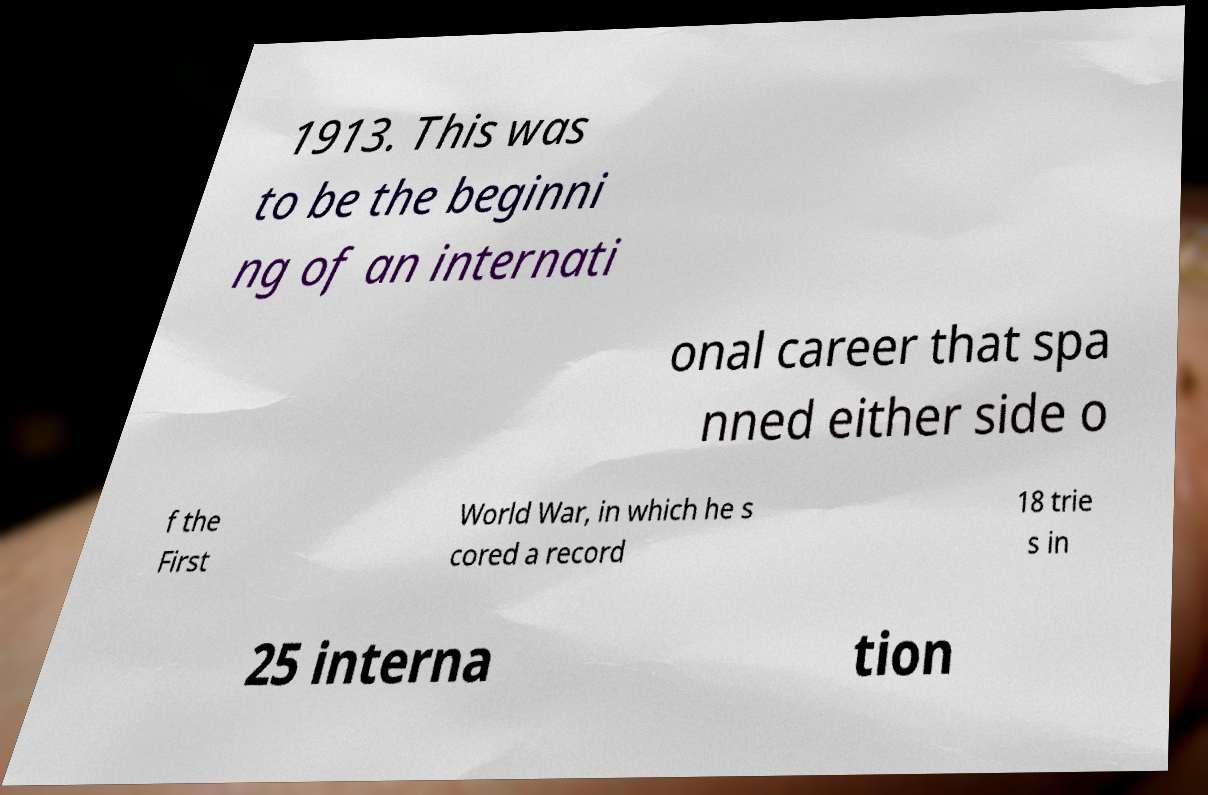Please identify and transcribe the text found in this image. 1913. This was to be the beginni ng of an internati onal career that spa nned either side o f the First World War, in which he s cored a record 18 trie s in 25 interna tion 